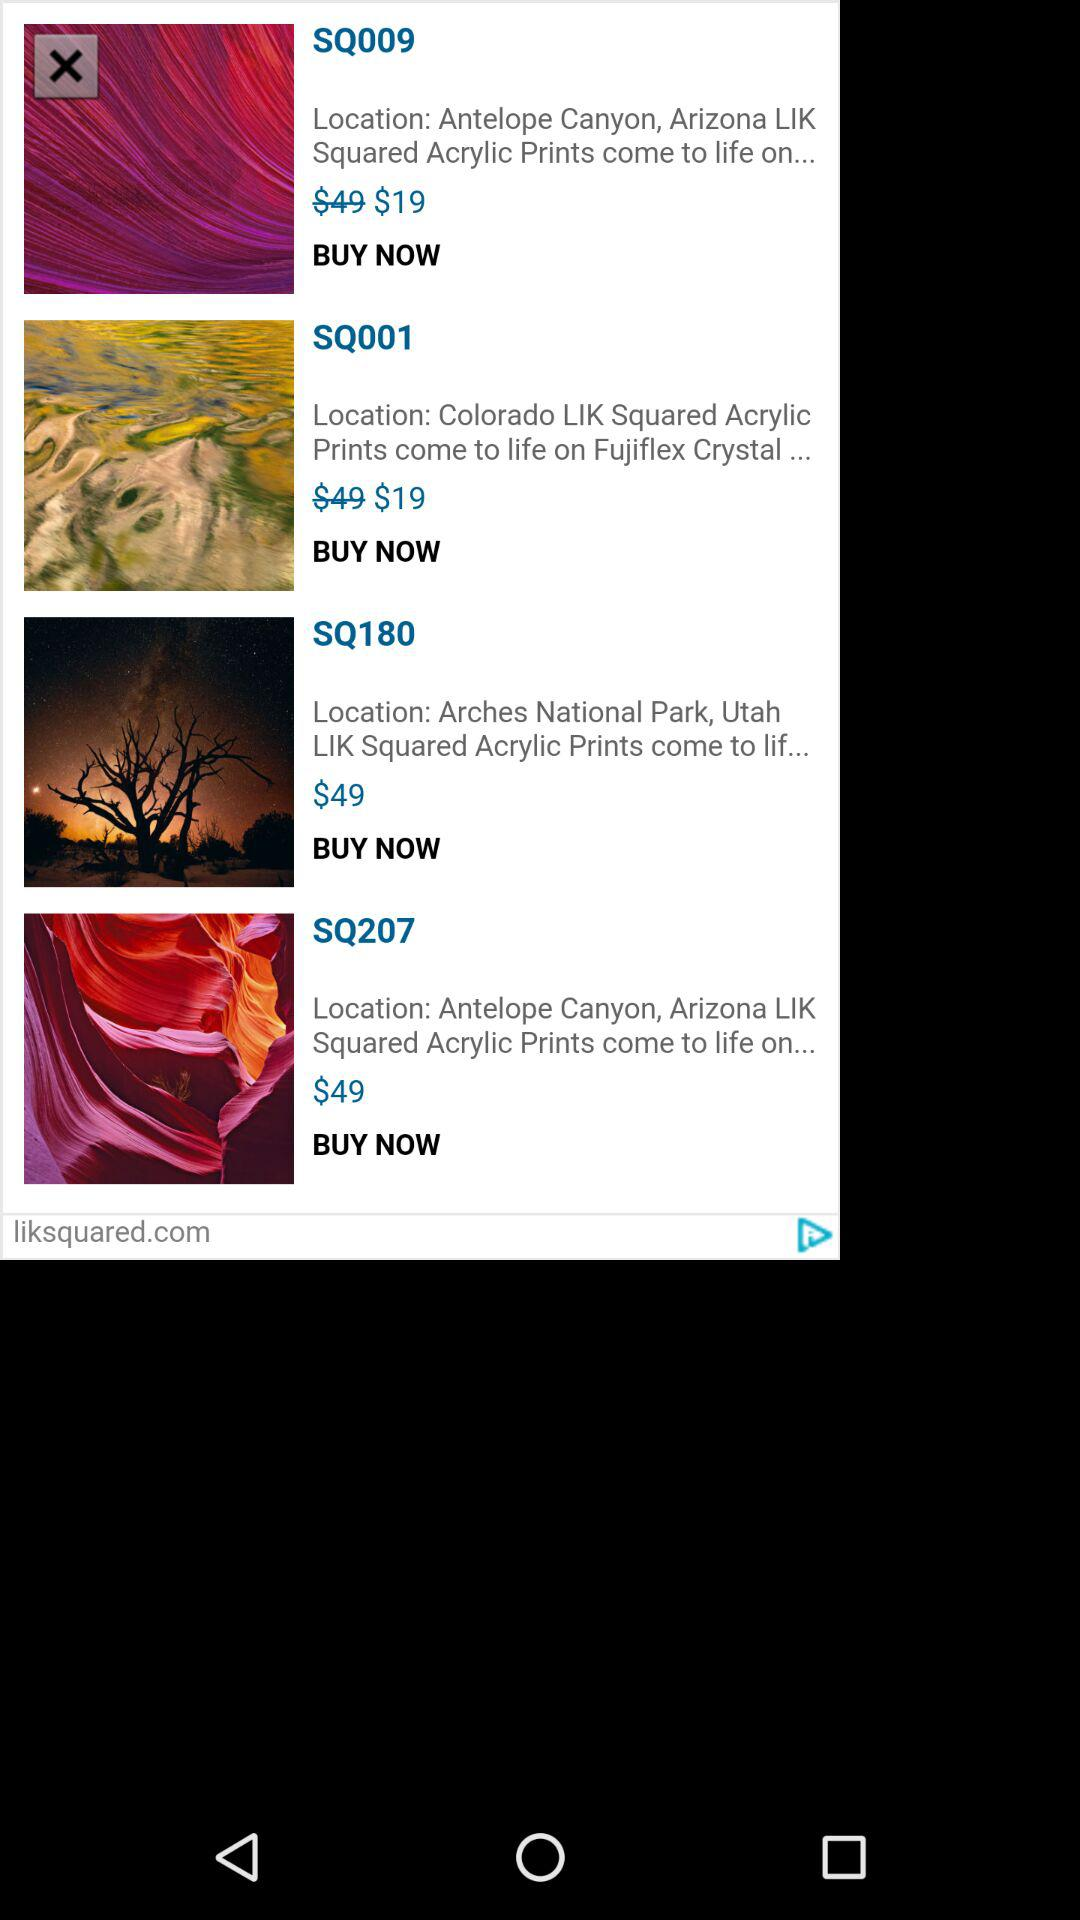What is the price of "SQ001"? The price is $19. 